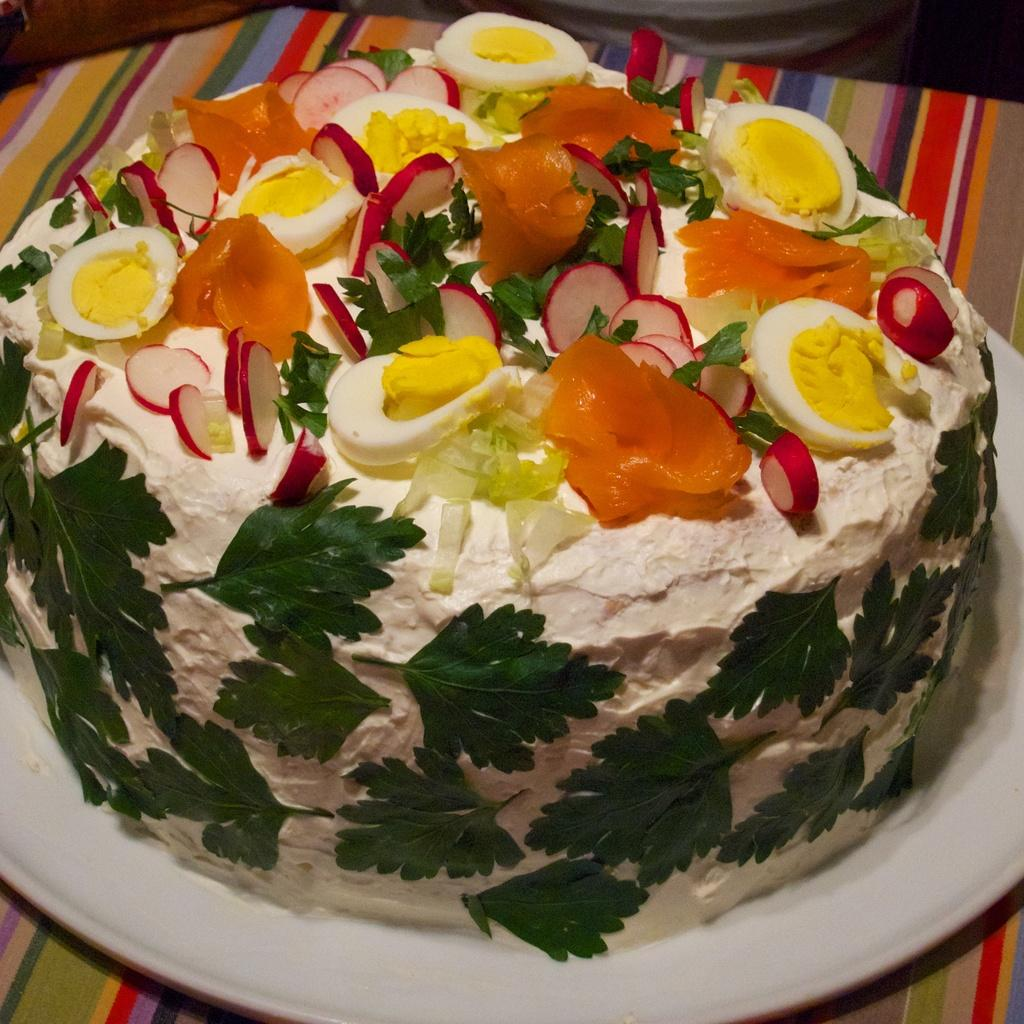What piece of furniture is present in the image? There is a table in the image. What is covering the table? The table has a cloth on it. What object is placed on the table? There is a plate on the table. What is on the plate? The plate contains a food item. What type of alarm is ringing in the image? There is no alarm present in the image. What kind of fruit can be seen on the table in the image? There is no fruit visible in the image; the plate contains a food item, but it is not specified as fruit. 